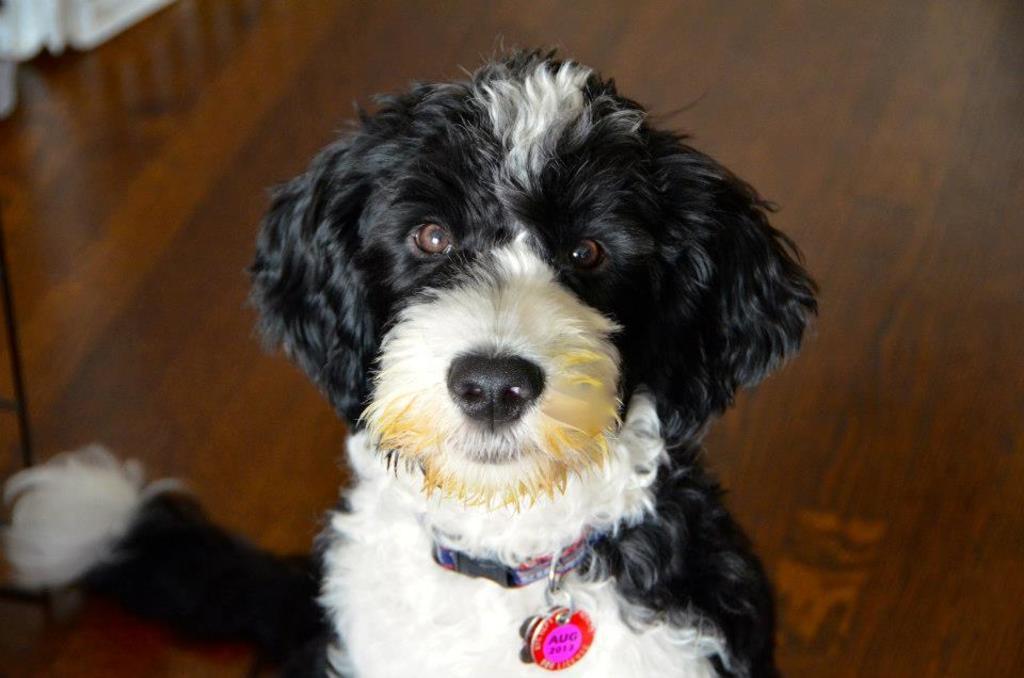Please provide a concise description of this image. In this image we can see a dog on the floor and on the left side there are objects on the floor. 